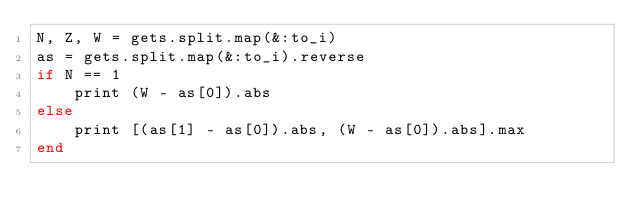Convert code to text. <code><loc_0><loc_0><loc_500><loc_500><_Ruby_>N, Z, W = gets.split.map(&:to_i)
as = gets.split.map(&:to_i).reverse
if N == 1
    print (W - as[0]).abs
else
    print [(as[1] - as[0]).abs, (W - as[0]).abs].max
end</code> 